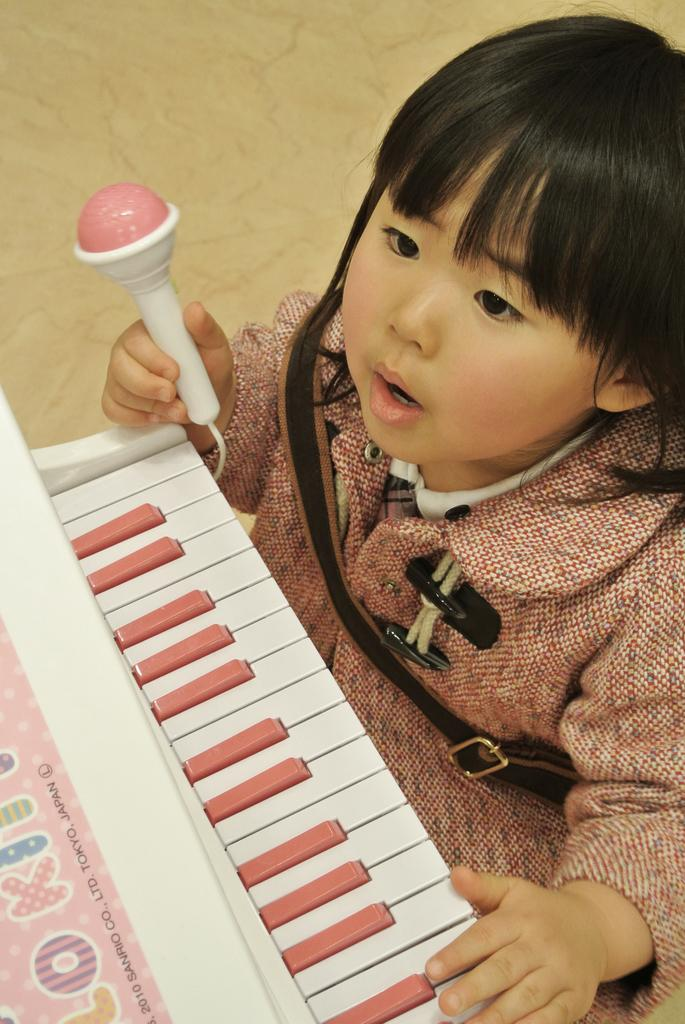Who is the main subject in the image? There is a girl in the image. What is the girl wearing? The girl is wearing a pink dress. What object is the girl holding in her right hand? The girl is holding a toy microphone in her right hand. What activity is the girl engaged in? The girl is playing the piano. What type of grain is visible in the image? There is no grain present in the image. What station is the girl tuning to on the toy microphone? The image does not show the girl tuning to a station on the toy microphone; it only shows her holding it. 